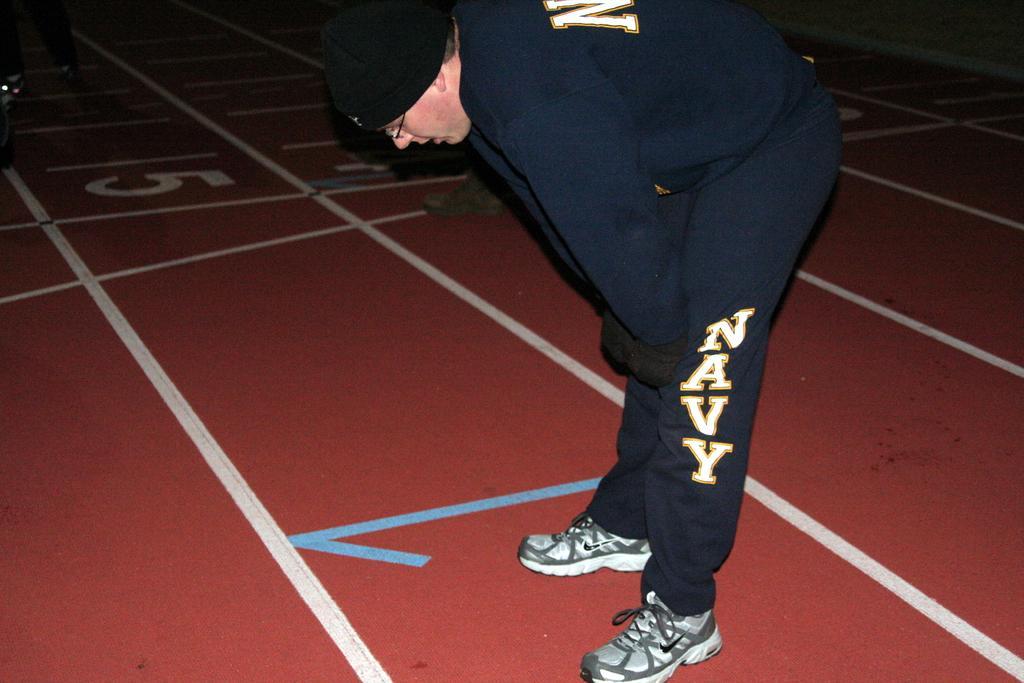Please provide a concise description of this image. This picture is clicked inside. In the center there is a person wearing blue color t-shirt, gloves, standing on the ground and bending forward. The ground is covered with the red color floor carpet and we can see the numbers on the carpet. 